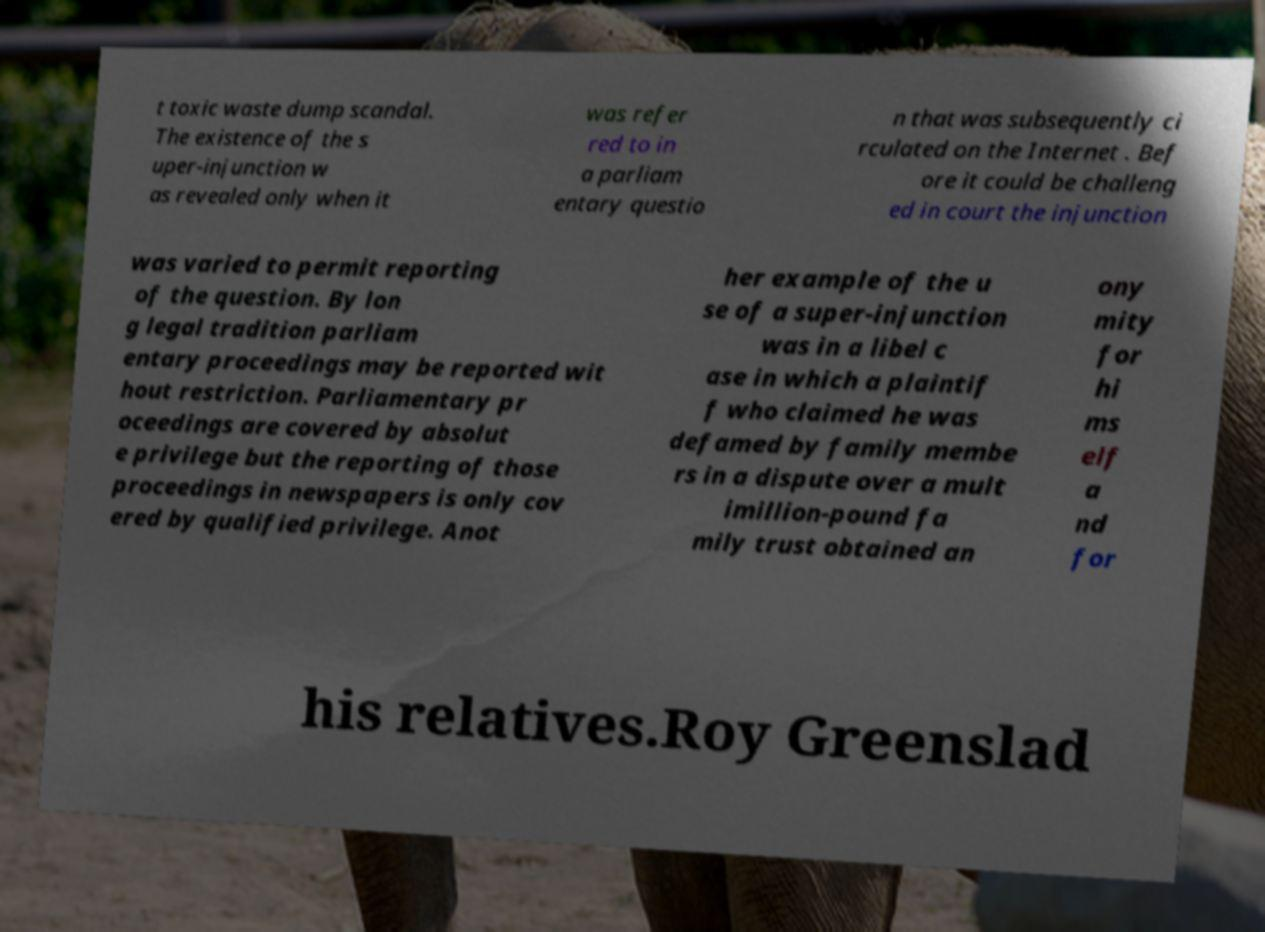Can you read and provide the text displayed in the image?This photo seems to have some interesting text. Can you extract and type it out for me? t toxic waste dump scandal. The existence of the s uper-injunction w as revealed only when it was refer red to in a parliam entary questio n that was subsequently ci rculated on the Internet . Bef ore it could be challeng ed in court the injunction was varied to permit reporting of the question. By lon g legal tradition parliam entary proceedings may be reported wit hout restriction. Parliamentary pr oceedings are covered by absolut e privilege but the reporting of those proceedings in newspapers is only cov ered by qualified privilege. Anot her example of the u se of a super-injunction was in a libel c ase in which a plaintif f who claimed he was defamed by family membe rs in a dispute over a mult imillion-pound fa mily trust obtained an ony mity for hi ms elf a nd for his relatives.Roy Greenslad 